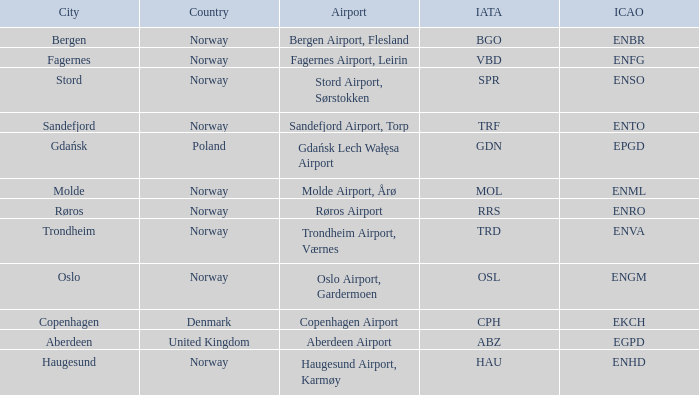What is the Airport in Oslo? Oslo Airport, Gardermoen. 